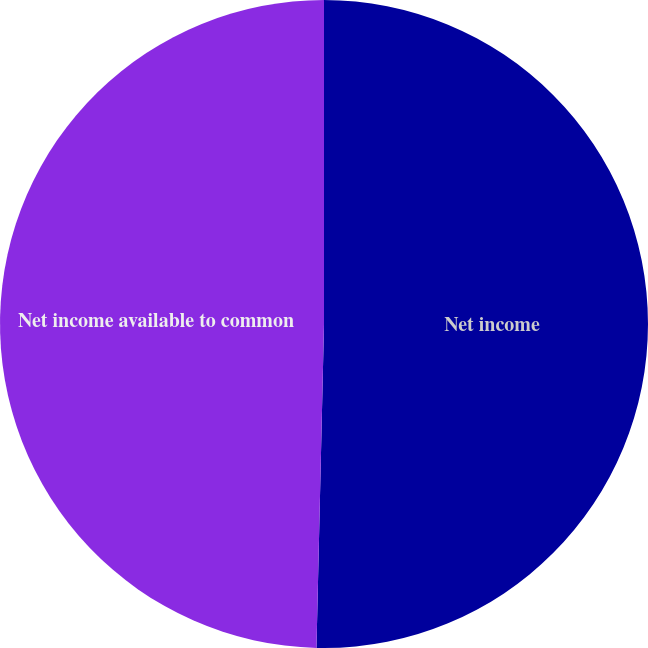<chart> <loc_0><loc_0><loc_500><loc_500><pie_chart><fcel>Net income<fcel>Net income available to common<nl><fcel>50.37%<fcel>49.63%<nl></chart> 